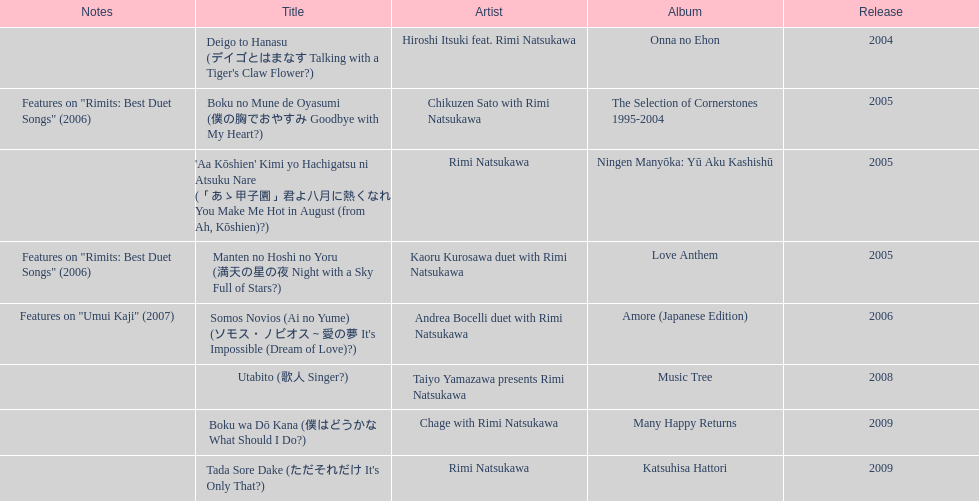What year was the first title released? 2004. 